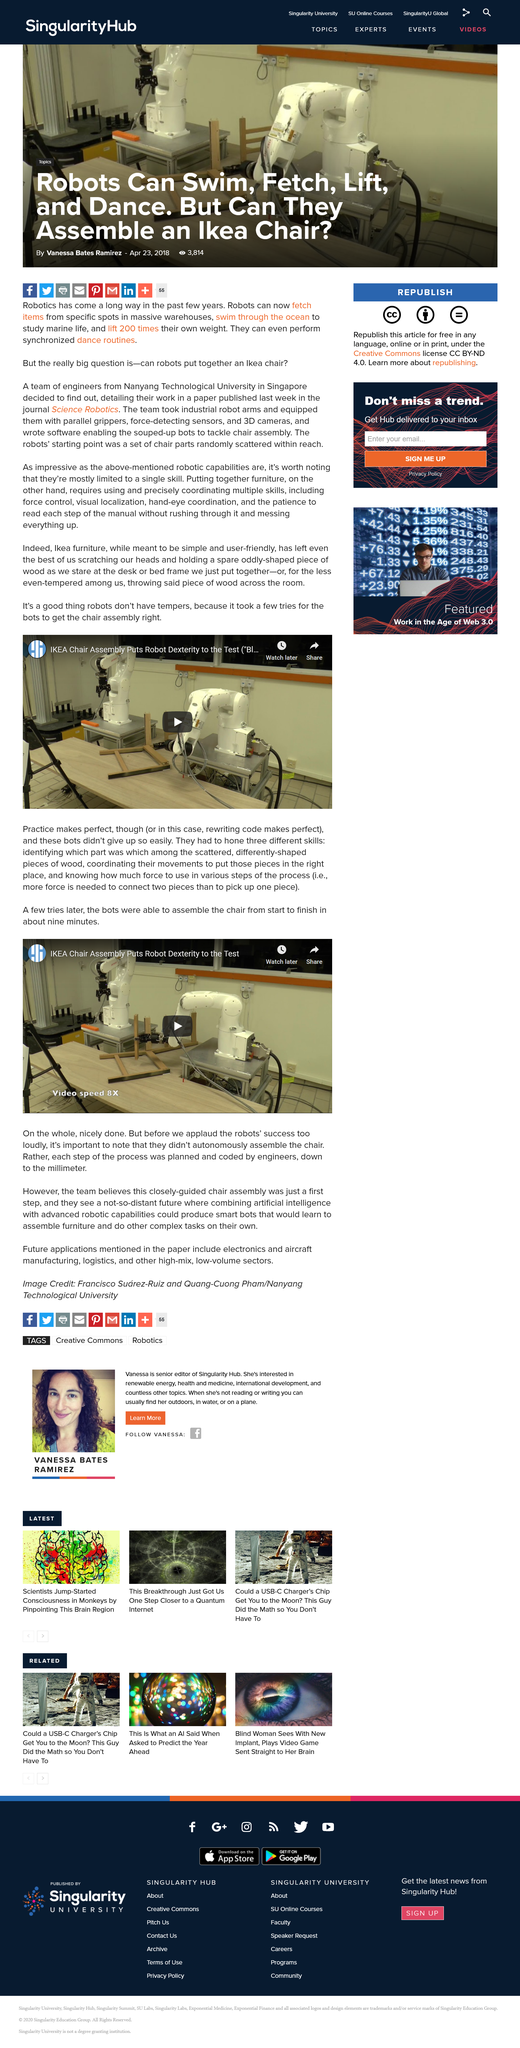Specify some key components in this picture. The machines had to hone three skills in order to achieve their goals. The company that produced the chairs was IKEA. The force required to pick up two pieces was greater than that required to pick up one piece, as determined by the experiment. 